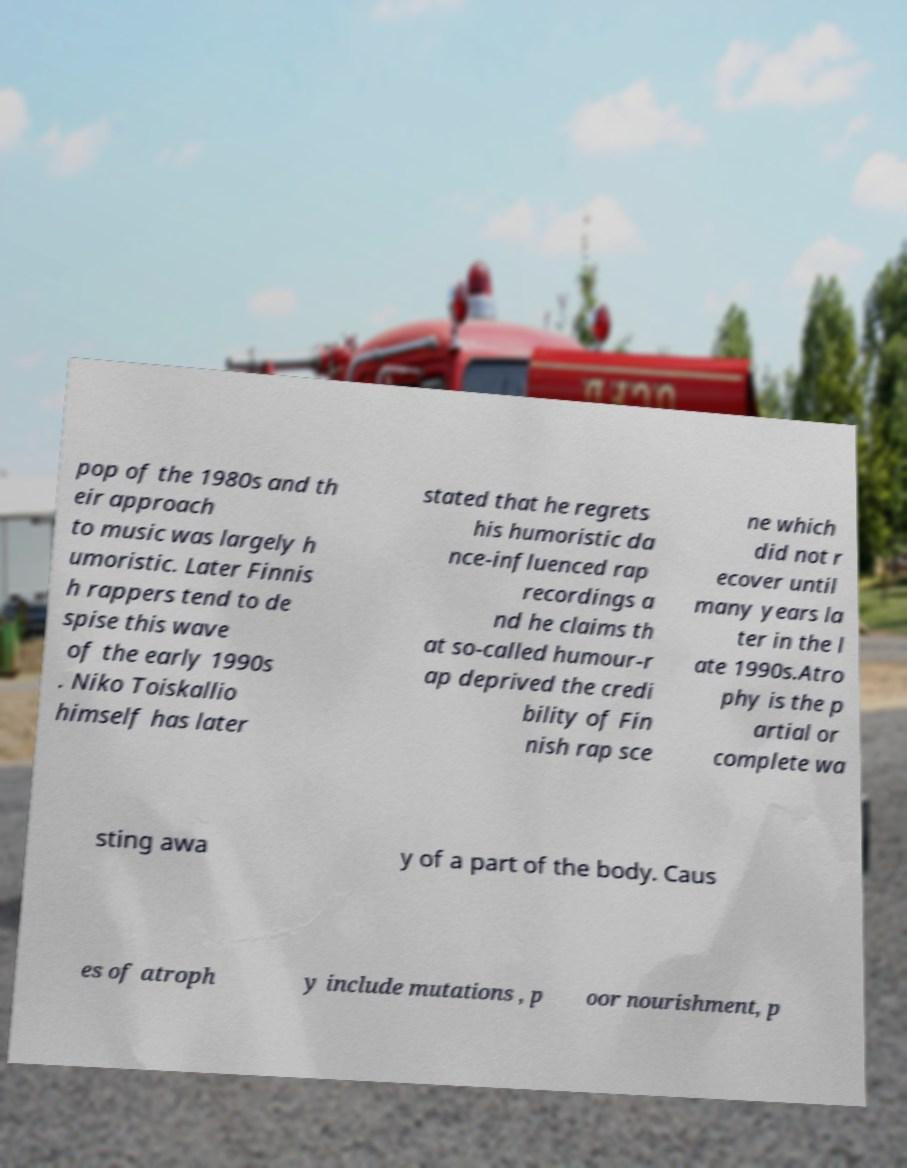Please read and relay the text visible in this image. What does it say? pop of the 1980s and th eir approach to music was largely h umoristic. Later Finnis h rappers tend to de spise this wave of the early 1990s . Niko Toiskallio himself has later stated that he regrets his humoristic da nce-influenced rap recordings a nd he claims th at so-called humour-r ap deprived the credi bility of Fin nish rap sce ne which did not r ecover until many years la ter in the l ate 1990s.Atro phy is the p artial or complete wa sting awa y of a part of the body. Caus es of atroph y include mutations , p oor nourishment, p 